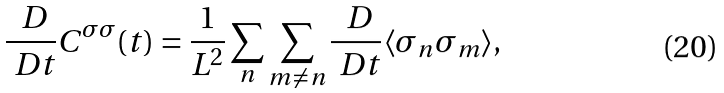<formula> <loc_0><loc_0><loc_500><loc_500>\frac { \ D } { \ D t } C ^ { \sigma \sigma } ( t ) = \frac { 1 } { L ^ { 2 } } \sum _ { n } \sum _ { m \ne n } \frac { \ D } { \ D t } \langle \sigma _ { n } \sigma _ { m } \rangle ,</formula> 